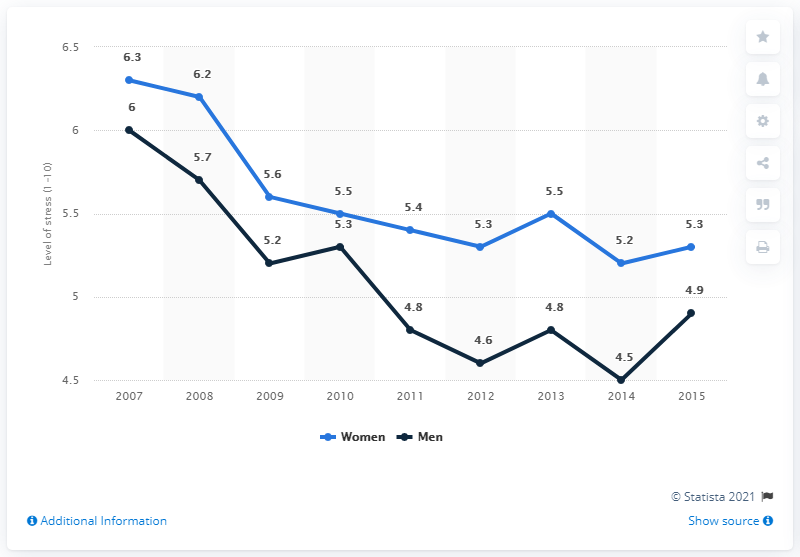Outline some significant characteristics in this image. In 2007, the average stress level among U.S. women was 6.3. The blue line data in 2014 was 5.2. The number of points that women have dropped from 2007 to 2015 is 6. 